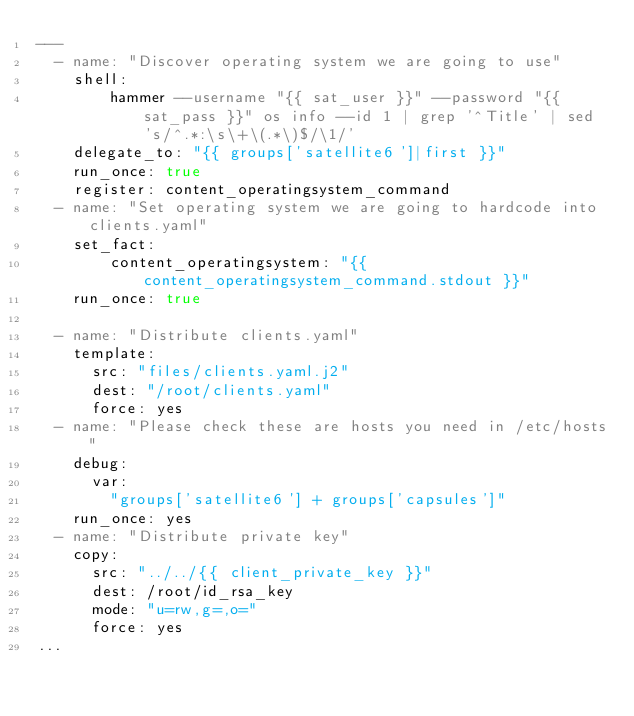Convert code to text. <code><loc_0><loc_0><loc_500><loc_500><_YAML_>---
  - name: "Discover operating system we are going to use"
    shell:
        hammer --username "{{ sat_user }}" --password "{{ sat_pass }}" os info --id 1 | grep '^Title' | sed 's/^.*:\s\+\(.*\)$/\1/'
    delegate_to: "{{ groups['satellite6']|first }}"
    run_once: true
    register: content_operatingsystem_command
  - name: "Set operating system we are going to hardcode into clients.yaml"
    set_fact:
        content_operatingsystem: "{{ content_operatingsystem_command.stdout }}"
    run_once: true

  - name: "Distribute clients.yaml"
    template:
      src: "files/clients.yaml.j2"
      dest: "/root/clients.yaml"
      force: yes
  - name: "Please check these are hosts you need in /etc/hosts"
    debug:
      var:
        "groups['satellite6'] + groups['capsules']"
    run_once: yes
  - name: "Distribute private key"
    copy:
      src: "../../{{ client_private_key }}"
      dest: /root/id_rsa_key
      mode: "u=rw,g=,o="
      force: yes
...
</code> 